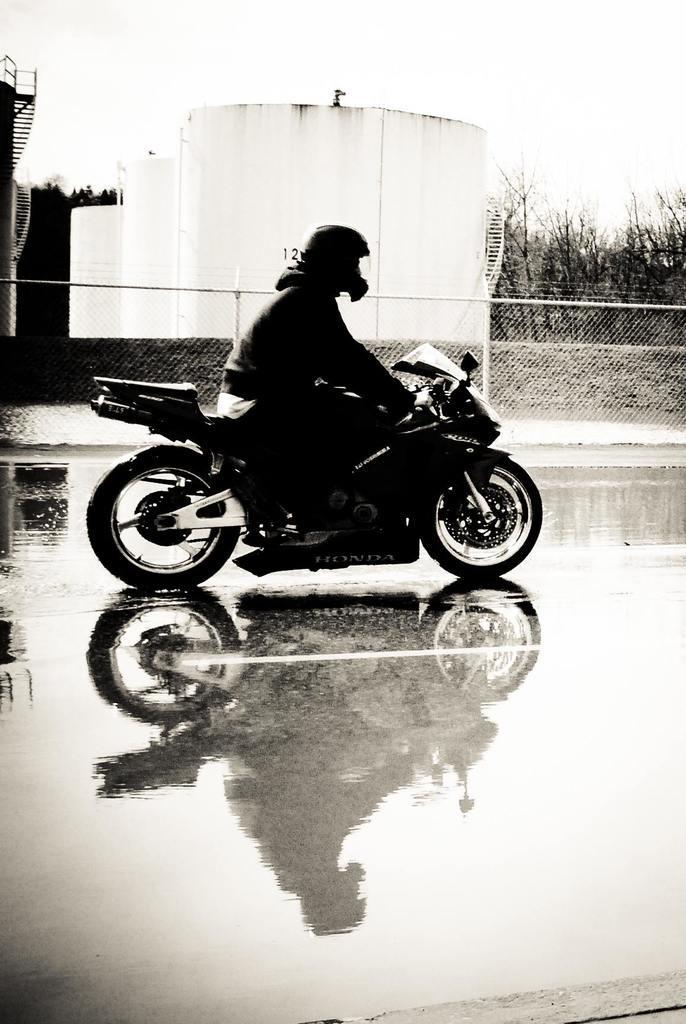How would you summarize this image in a sentence or two? In this image their is a man who is riding the motorcycle with a helmet on his head. At the background there are tanks,trees and a fence. At the bottom there is a water. 